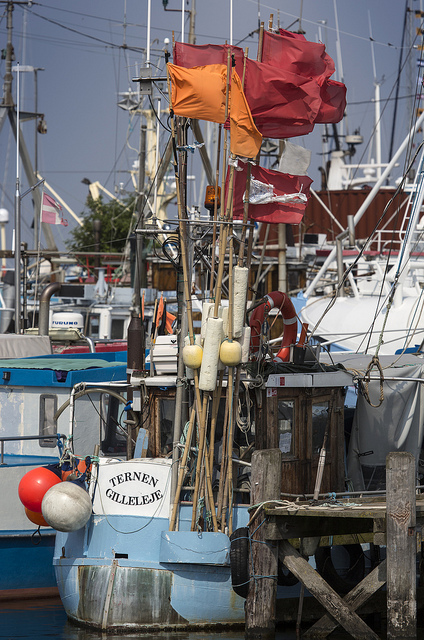Please transcribe the text information in this image. TERNEN GILLELEJE 